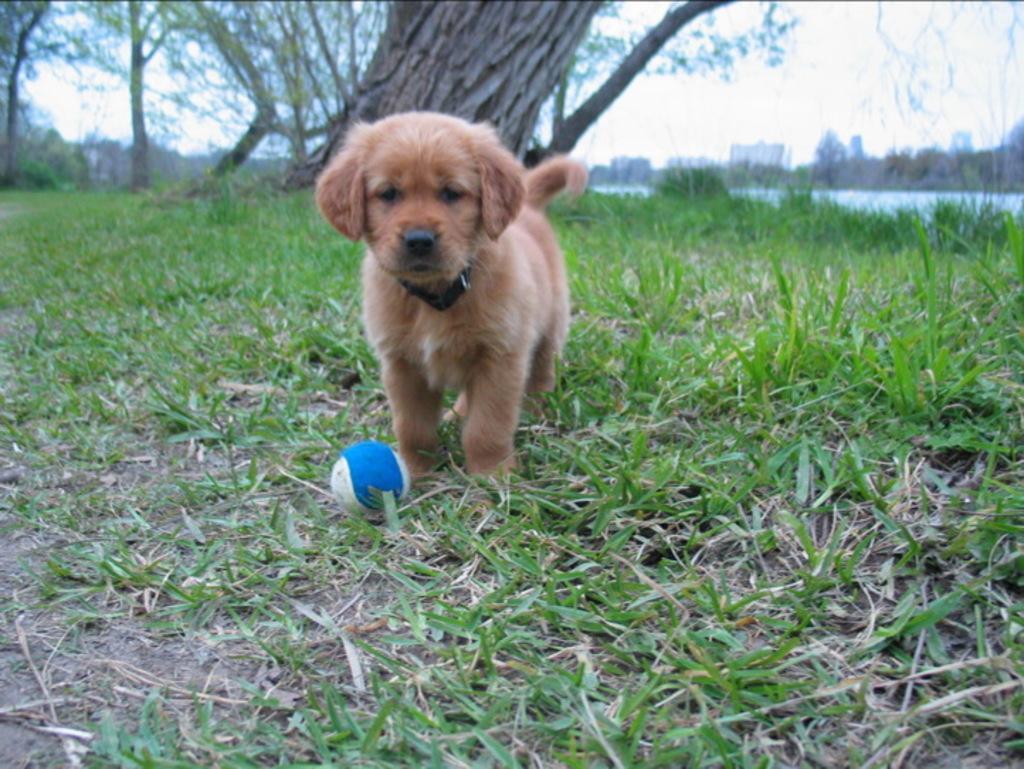In one or two sentences, can you explain what this image depicts? In this image I can see the dog which is in brown color and it is on the grass. I can see the ball In-front of the dog. In the background I can see many trees, water and the sky. 